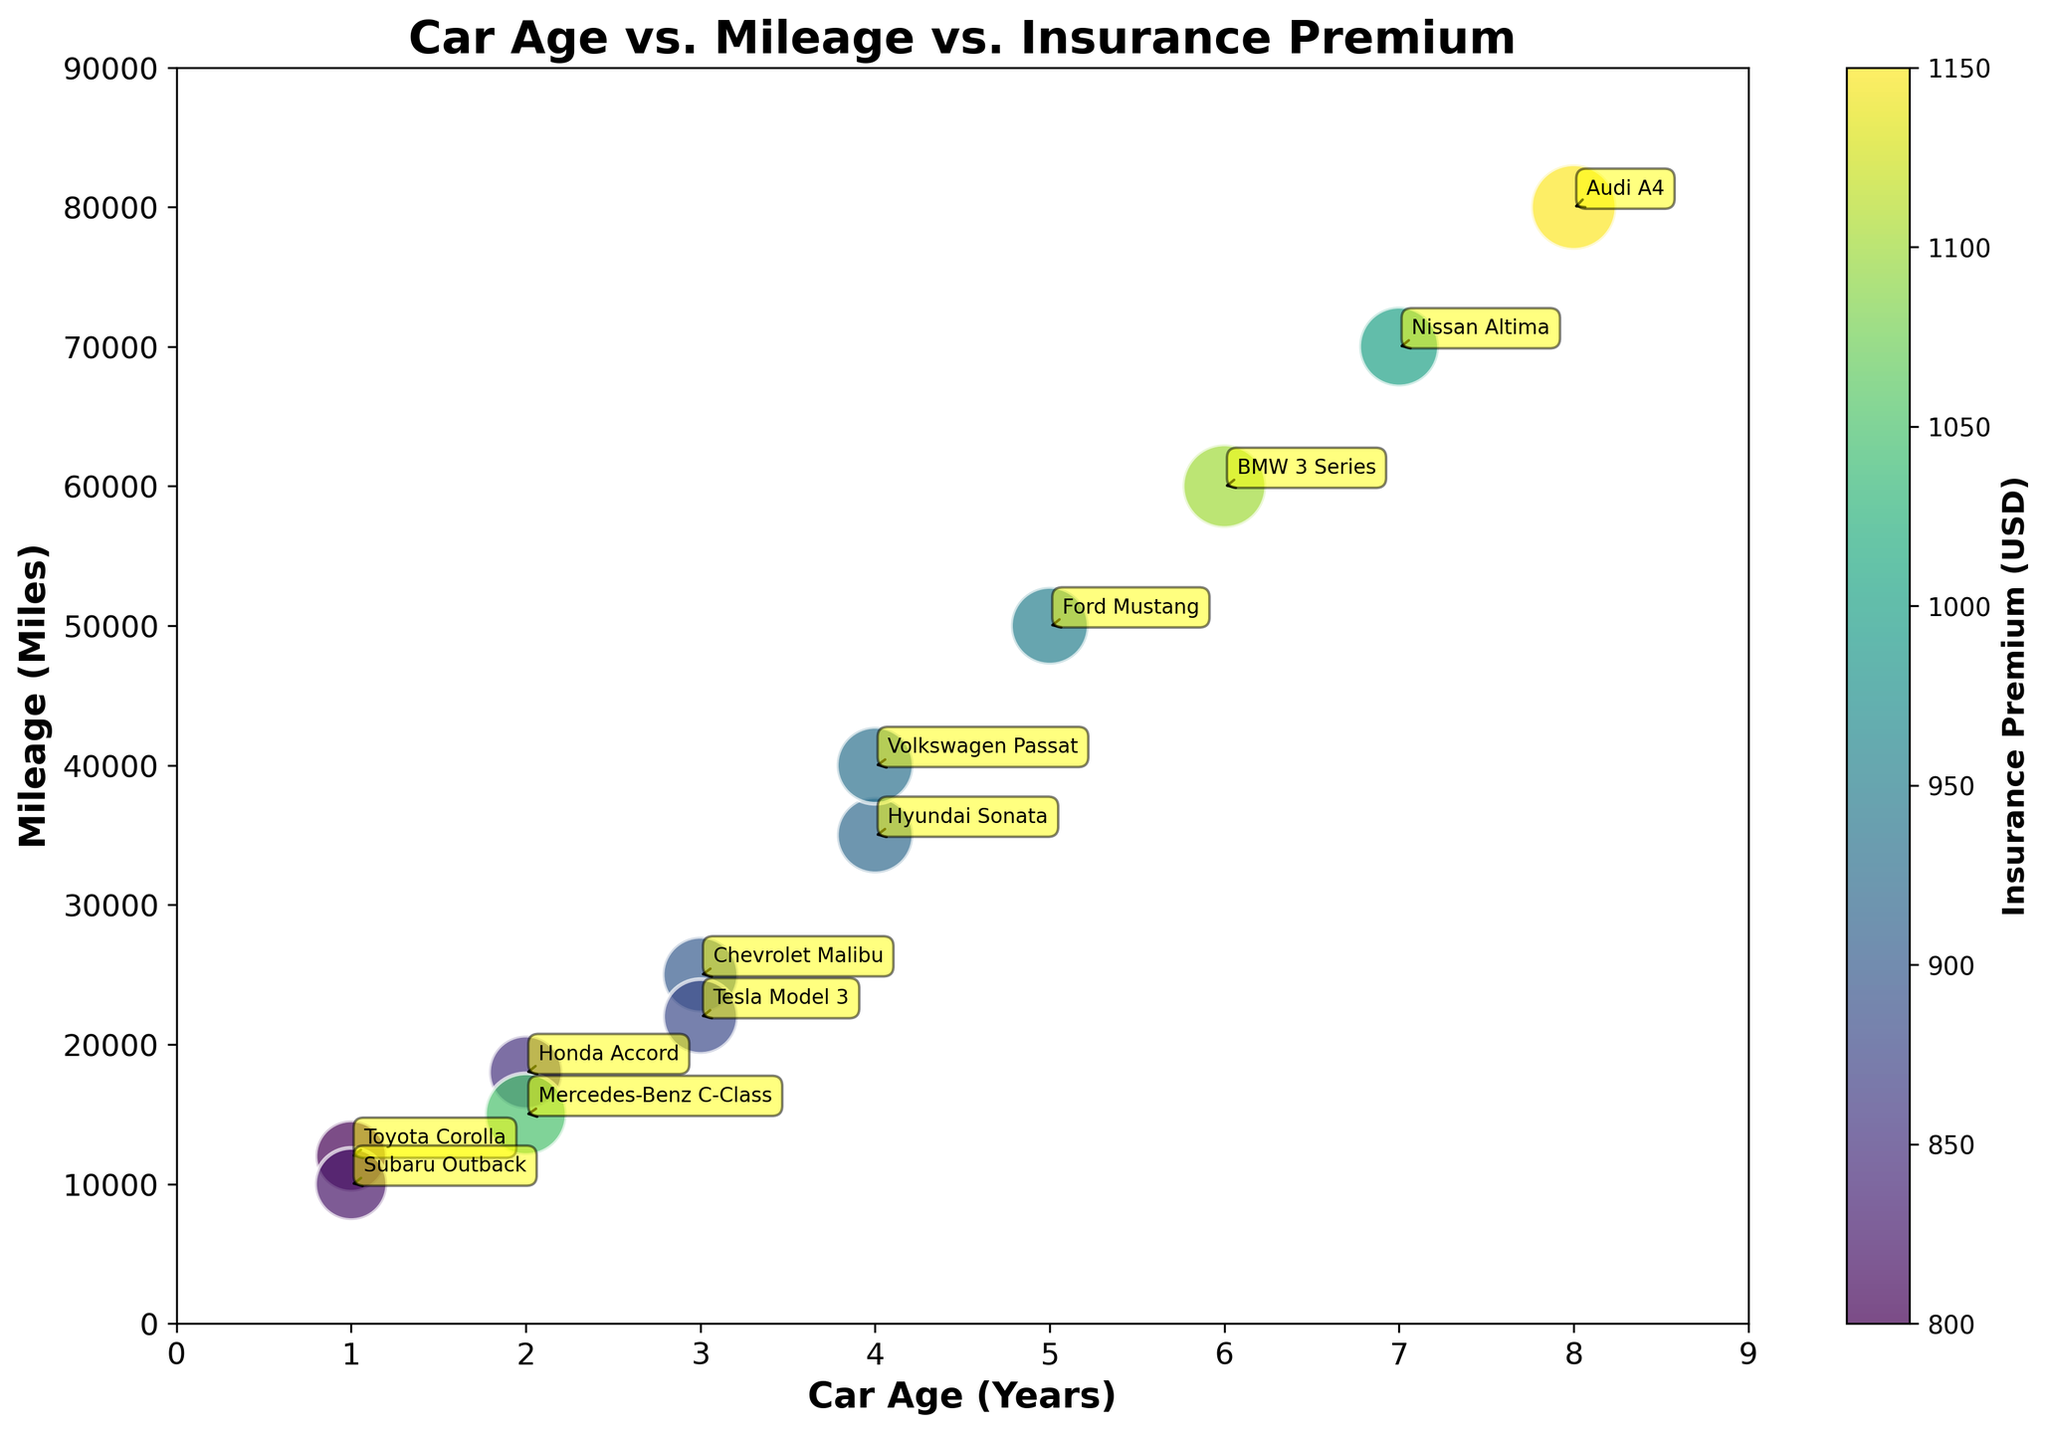How many data points are shown in the chart? The chart shows data points for each car model present in the dataset. Counting the car models gives the total number of data points.
Answer: 12 What's the title of the chart? The title of the chart can be found at the top of the figure.
Answer: Car Age vs. Mileage vs. Insurance Premium Which car model has the highest insurance premium? By observing the color intensity and size of the bubbles, we can find the model with the highest insurance premium. The color bar can help confirm this. The car model with the highest premium has the darkest color and largest size bubble.
Answer: Audi A4 What is the average mileage for cars that are 3 years old? Identify the cars that are 3 years old, then sum their mileages and divide by the number of such cars.
Answer: (25000 + 22000) / 2 = 23500 Is there any car model that appears significantly outside the general trend in terms of age, mileage, and premium? Observing the scatter plot for any data point that significantly deviates in position or size compared to others can help identify such anomalies.
Answer: BMW 3 Series Which car model has a higher insurance premium: Ford Mustang or Hyundai Sonata? Look at the bubbles representing the Ford Mustang and Hyundai Sonata. Compare their color and size according to the color bar and bubble size.
Answer: Ford Mustang What is the range of car ages shown in the chart? The range can be determined by finding the minimum and maximum car ages from the x-axis values.
Answer: 1 to 8 years Do older cars generally have higher mileages? By observing the scatter plot, see if there is an upward trend in mileage values as car age increases.
Answer: Yes How does the insurance premium of the Mercedes-Benz C-Class compare to the Audi A4? Compare the two bubbles based on their size and color intensity highlighted in the color bar.
Answer: The Audi A4 has a higher insurance premium Which car model has the lowest mileage among those with an insurance premium above 1000 USD? Identify the bubbles with colors indicating premiums above 1000 USD and compare their mileage values.
Answer: Mercedes-Benz C-Class 